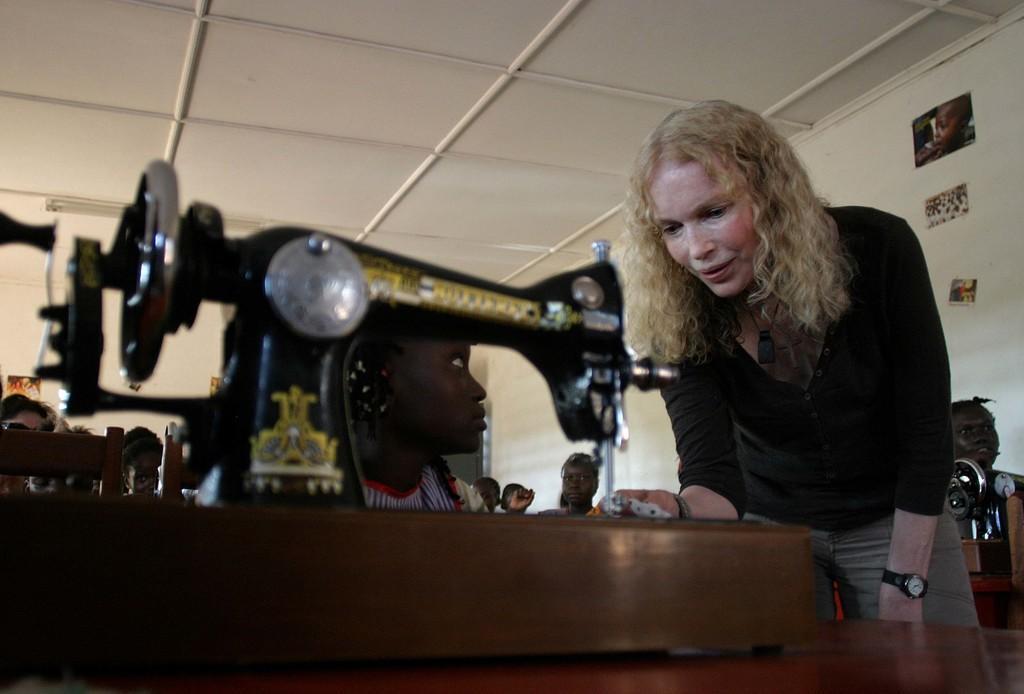Can you describe this image briefly? There one woman standing and wearing a black color t shirt on the right side of this image, and there is sewing machine as we can see at the bottom of this image. There are some persons in the background. We can see there is a wall behind to these persons. 